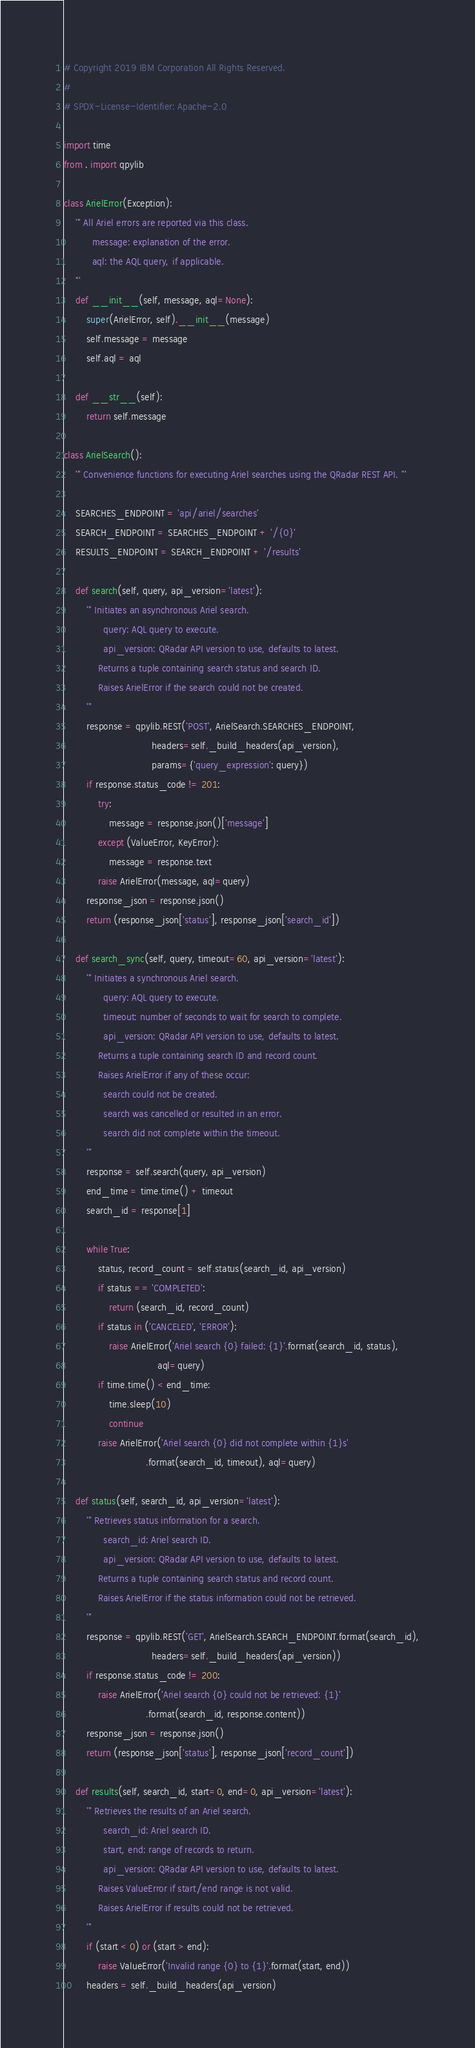Convert code to text. <code><loc_0><loc_0><loc_500><loc_500><_Python_># Copyright 2019 IBM Corporation All Rights Reserved.
#
# SPDX-License-Identifier: Apache-2.0

import time
from . import qpylib

class ArielError(Exception):
    ''' All Ariel errors are reported via this class.
          message: explanation of the error.
          aql: the AQL query, if applicable.
    '''
    def __init__(self, message, aql=None):
        super(ArielError, self).__init__(message)
        self.message = message
        self.aql = aql

    def __str__(self):
        return self.message

class ArielSearch():
    ''' Convenience functions for executing Ariel searches using the QRadar REST API. '''

    SEARCHES_ENDPOINT = 'api/ariel/searches'
    SEARCH_ENDPOINT = SEARCHES_ENDPOINT + '/{0}'
    RESULTS_ENDPOINT = SEARCH_ENDPOINT + '/results'

    def search(self, query, api_version='latest'):
        ''' Initiates an asynchronous Ariel search.
              query: AQL query to execute.
              api_version: QRadar API version to use, defaults to latest.
            Returns a tuple containing search status and search ID.
            Raises ArielError if the search could not be created.
        '''
        response = qpylib.REST('POST', ArielSearch.SEARCHES_ENDPOINT,
                               headers=self._build_headers(api_version),
                               params={'query_expression': query})
        if response.status_code != 201:
            try:
                message = response.json()['message']
            except (ValueError, KeyError):
                message = response.text
            raise ArielError(message, aql=query)
        response_json = response.json()
        return (response_json['status'], response_json['search_id'])

    def search_sync(self, query, timeout=60, api_version='latest'):
        ''' Initiates a synchronous Ariel search.
              query: AQL query to execute.
              timeout: number of seconds to wait for search to complete.
              api_version: QRadar API version to use, defaults to latest.
            Returns a tuple containing search ID and record count.
            Raises ArielError if any of these occur:
              search could not be created.
              search was cancelled or resulted in an error.
              search did not complete within the timeout.
        '''
        response = self.search(query, api_version)
        end_time = time.time() + timeout
        search_id = response[1]

        while True:
            status, record_count = self.status(search_id, api_version)
            if status == 'COMPLETED':
                return (search_id, record_count)
            if status in ('CANCELED', 'ERROR'):
                raise ArielError('Ariel search {0} failed: {1}'.format(search_id, status),
                                 aql=query)
            if time.time() < end_time:
                time.sleep(10)
                continue
            raise ArielError('Ariel search {0} did not complete within {1}s'
                             .format(search_id, timeout), aql=query)

    def status(self, search_id, api_version='latest'):
        ''' Retrieves status information for a search.
              search_id: Ariel search ID.
              api_version: QRadar API version to use, defaults to latest.
            Returns a tuple containing search status and record count.
            Raises ArielError if the status information could not be retrieved.
        '''
        response = qpylib.REST('GET', ArielSearch.SEARCH_ENDPOINT.format(search_id),
                               headers=self._build_headers(api_version))
        if response.status_code != 200:
            raise ArielError('Ariel search {0} could not be retrieved: {1}'
                             .format(search_id, response.content))
        response_json = response.json()
        return (response_json['status'], response_json['record_count'])

    def results(self, search_id, start=0, end=0, api_version='latest'):
        ''' Retrieves the results of an Ariel search.
              search_id: Ariel search ID.
              start, end: range of records to return.
              api_version: QRadar API version to use, defaults to latest.
            Raises ValueError if start/end range is not valid.
            Raises ArielError if results could not be retrieved.
        '''
        if (start < 0) or (start > end):
            raise ValueError('Invalid range {0} to {1}'.format(start, end))
        headers = self._build_headers(api_version)</code> 